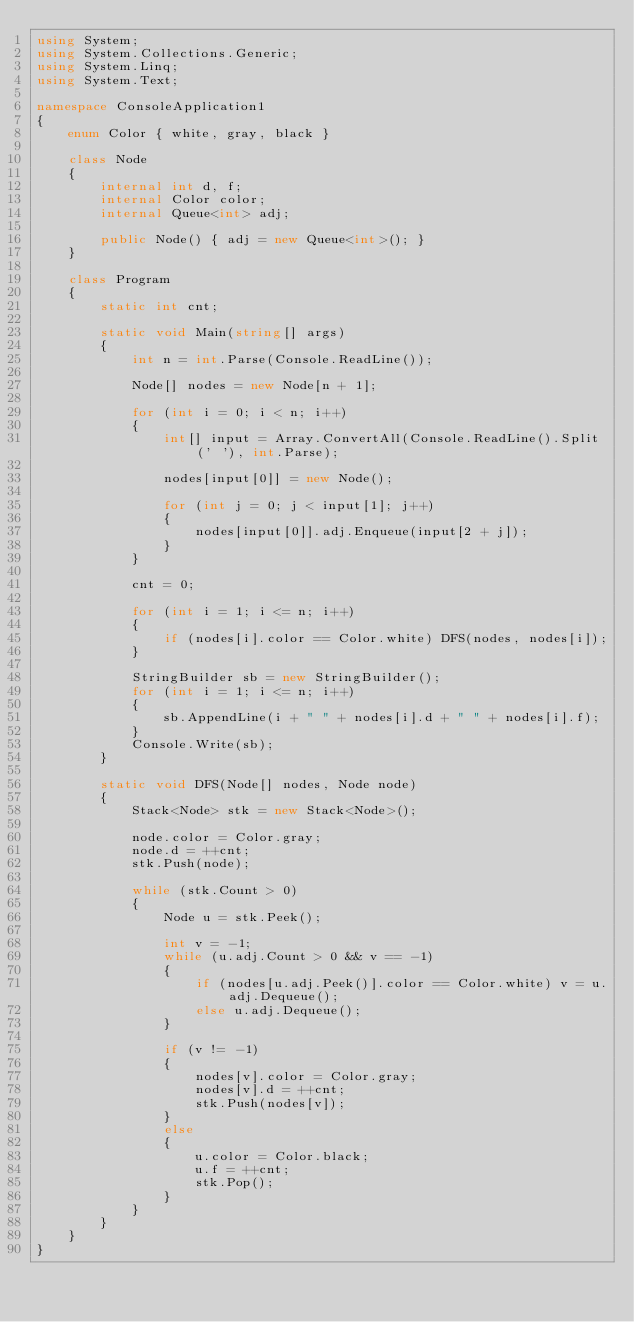Convert code to text. <code><loc_0><loc_0><loc_500><loc_500><_C#_>using System;
using System.Collections.Generic;
using System.Linq;
using System.Text;

namespace ConsoleApplication1
{
    enum Color { white, gray, black }

    class Node
    {
        internal int d, f;
        internal Color color;
        internal Queue<int> adj;

        public Node() { adj = new Queue<int>(); }
    }

    class Program
    {
        static int cnt;

        static void Main(string[] args)
        {
            int n = int.Parse(Console.ReadLine());

            Node[] nodes = new Node[n + 1];

            for (int i = 0; i < n; i++)
            {
                int[] input = Array.ConvertAll(Console.ReadLine().Split(' '), int.Parse);

                nodes[input[0]] = new Node();

                for (int j = 0; j < input[1]; j++)
                {
                    nodes[input[0]].adj.Enqueue(input[2 + j]);
                }
            }

            cnt = 0;

            for (int i = 1; i <= n; i++)
            {
                if (nodes[i].color == Color.white) DFS(nodes, nodes[i]);
            }

            StringBuilder sb = new StringBuilder();
            for (int i = 1; i <= n; i++)
            {
                sb.AppendLine(i + " " + nodes[i].d + " " + nodes[i].f);
            }
            Console.Write(sb);
        }

        static void DFS(Node[] nodes, Node node)
        {
            Stack<Node> stk = new Stack<Node>();

            node.color = Color.gray;
            node.d = ++cnt;
            stk.Push(node);

            while (stk.Count > 0)
            {
                Node u = stk.Peek();

                int v = -1;
                while (u.adj.Count > 0 && v == -1)
                {
                    if (nodes[u.adj.Peek()].color == Color.white) v = u.adj.Dequeue();
                    else u.adj.Dequeue();
                }

                if (v != -1)
                {
                    nodes[v].color = Color.gray;
                    nodes[v].d = ++cnt;
                    stk.Push(nodes[v]);
                }
                else
                {
                    u.color = Color.black;
                    u.f = ++cnt;
                    stk.Pop();
                }
            }
        }
    }
}</code> 